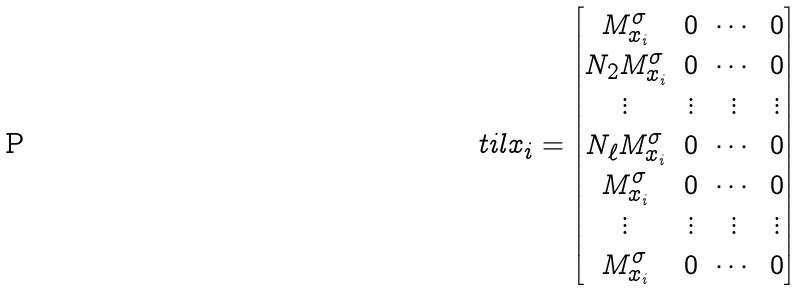<formula> <loc_0><loc_0><loc_500><loc_500>\ t i l x _ { i } = \begin{bmatrix} M _ { x _ { i } } ^ { \sigma } & 0 & \cdots & 0 \\ N _ { 2 } M _ { x _ { i } } ^ { \sigma } & 0 & \cdots & 0 \\ \vdots & \vdots & \vdots & \vdots \\ N _ { \ell } M _ { x _ { i } } ^ { \sigma } & 0 & \cdots & 0 \\ M _ { x _ { i } } ^ { \sigma } & 0 & \cdots & 0 \\ \vdots & \vdots & \vdots & \vdots \\ M _ { x _ { i } } ^ { \sigma } & 0 & \cdots & 0 \end{bmatrix}</formula> 